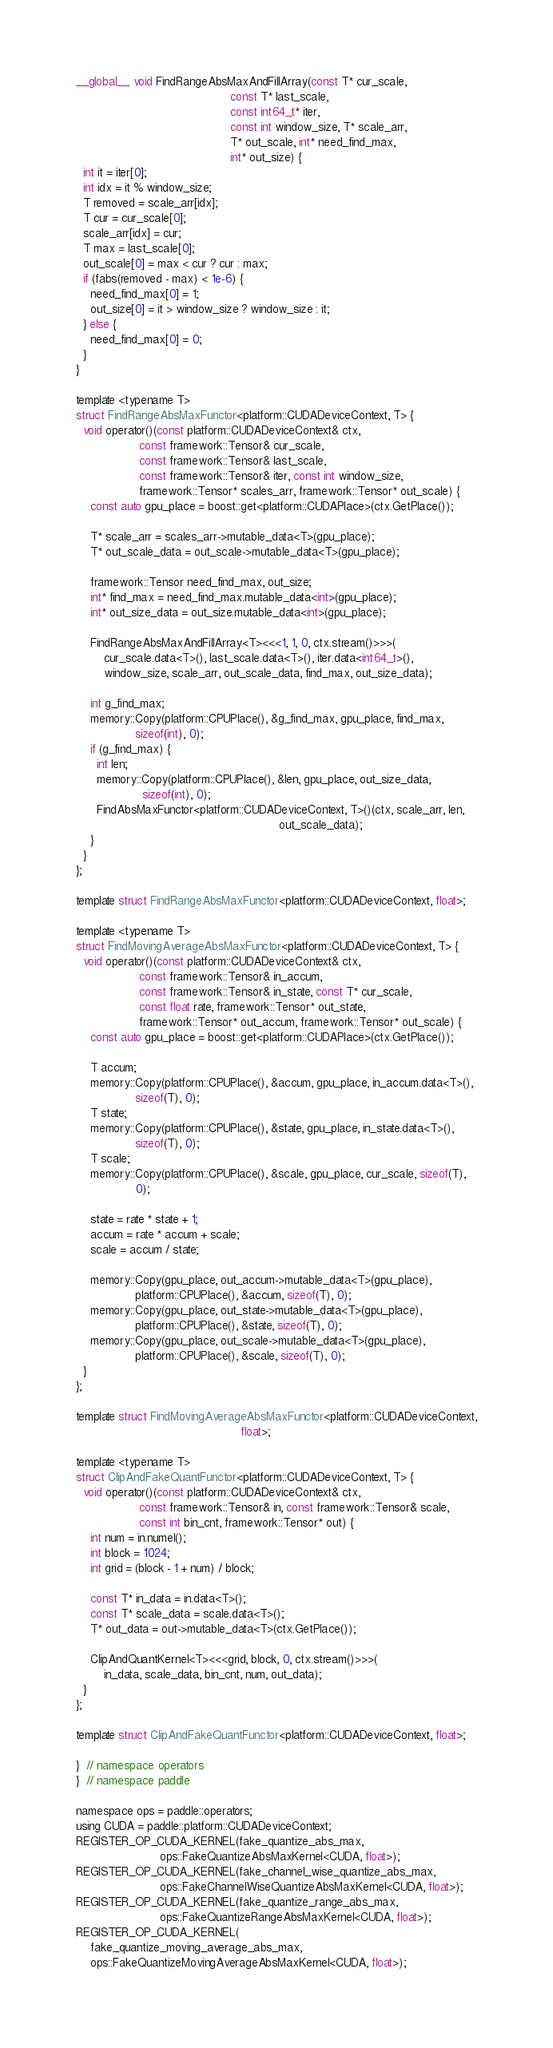<code> <loc_0><loc_0><loc_500><loc_500><_Cuda_>__global__ void FindRangeAbsMaxAndFillArray(const T* cur_scale,
                                            const T* last_scale,
                                            const int64_t* iter,
                                            const int window_size, T* scale_arr,
                                            T* out_scale, int* need_find_max,
                                            int* out_size) {
  int it = iter[0];
  int idx = it % window_size;
  T removed = scale_arr[idx];
  T cur = cur_scale[0];
  scale_arr[idx] = cur;
  T max = last_scale[0];
  out_scale[0] = max < cur ? cur : max;
  if (fabs(removed - max) < 1e-6) {
    need_find_max[0] = 1;
    out_size[0] = it > window_size ? window_size : it;
  } else {
    need_find_max[0] = 0;
  }
}

template <typename T>
struct FindRangeAbsMaxFunctor<platform::CUDADeviceContext, T> {
  void operator()(const platform::CUDADeviceContext& ctx,
                  const framework::Tensor& cur_scale,
                  const framework::Tensor& last_scale,
                  const framework::Tensor& iter, const int window_size,
                  framework::Tensor* scales_arr, framework::Tensor* out_scale) {
    const auto gpu_place = boost::get<platform::CUDAPlace>(ctx.GetPlace());

    T* scale_arr = scales_arr->mutable_data<T>(gpu_place);
    T* out_scale_data = out_scale->mutable_data<T>(gpu_place);

    framework::Tensor need_find_max, out_size;
    int* find_max = need_find_max.mutable_data<int>(gpu_place);
    int* out_size_data = out_size.mutable_data<int>(gpu_place);

    FindRangeAbsMaxAndFillArray<T><<<1, 1, 0, ctx.stream()>>>(
        cur_scale.data<T>(), last_scale.data<T>(), iter.data<int64_t>(),
        window_size, scale_arr, out_scale_data, find_max, out_size_data);

    int g_find_max;
    memory::Copy(platform::CPUPlace(), &g_find_max, gpu_place, find_max,
                 sizeof(int), 0);
    if (g_find_max) {
      int len;
      memory::Copy(platform::CPUPlace(), &len, gpu_place, out_size_data,
                   sizeof(int), 0);
      FindAbsMaxFunctor<platform::CUDADeviceContext, T>()(ctx, scale_arr, len,
                                                          out_scale_data);
    }
  }
};

template struct FindRangeAbsMaxFunctor<platform::CUDADeviceContext, float>;

template <typename T>
struct FindMovingAverageAbsMaxFunctor<platform::CUDADeviceContext, T> {
  void operator()(const platform::CUDADeviceContext& ctx,
                  const framework::Tensor& in_accum,
                  const framework::Tensor& in_state, const T* cur_scale,
                  const float rate, framework::Tensor* out_state,
                  framework::Tensor* out_accum, framework::Tensor* out_scale) {
    const auto gpu_place = boost::get<platform::CUDAPlace>(ctx.GetPlace());

    T accum;
    memory::Copy(platform::CPUPlace(), &accum, gpu_place, in_accum.data<T>(),
                 sizeof(T), 0);
    T state;
    memory::Copy(platform::CPUPlace(), &state, gpu_place, in_state.data<T>(),
                 sizeof(T), 0);
    T scale;
    memory::Copy(platform::CPUPlace(), &scale, gpu_place, cur_scale, sizeof(T),
                 0);

    state = rate * state + 1;
    accum = rate * accum + scale;
    scale = accum / state;

    memory::Copy(gpu_place, out_accum->mutable_data<T>(gpu_place),
                 platform::CPUPlace(), &accum, sizeof(T), 0);
    memory::Copy(gpu_place, out_state->mutable_data<T>(gpu_place),
                 platform::CPUPlace(), &state, sizeof(T), 0);
    memory::Copy(gpu_place, out_scale->mutable_data<T>(gpu_place),
                 platform::CPUPlace(), &scale, sizeof(T), 0);
  }
};

template struct FindMovingAverageAbsMaxFunctor<platform::CUDADeviceContext,
                                               float>;

template <typename T>
struct ClipAndFakeQuantFunctor<platform::CUDADeviceContext, T> {
  void operator()(const platform::CUDADeviceContext& ctx,
                  const framework::Tensor& in, const framework::Tensor& scale,
                  const int bin_cnt, framework::Tensor* out) {
    int num = in.numel();
    int block = 1024;
    int grid = (block - 1 + num) / block;

    const T* in_data = in.data<T>();
    const T* scale_data = scale.data<T>();
    T* out_data = out->mutable_data<T>(ctx.GetPlace());

    ClipAndQuantKernel<T><<<grid, block, 0, ctx.stream()>>>(
        in_data, scale_data, bin_cnt, num, out_data);
  }
};

template struct ClipAndFakeQuantFunctor<platform::CUDADeviceContext, float>;

}  // namespace operators
}  // namespace paddle

namespace ops = paddle::operators;
using CUDA = paddle::platform::CUDADeviceContext;
REGISTER_OP_CUDA_KERNEL(fake_quantize_abs_max,
                        ops::FakeQuantizeAbsMaxKernel<CUDA, float>);
REGISTER_OP_CUDA_KERNEL(fake_channel_wise_quantize_abs_max,
                        ops::FakeChannelWiseQuantizeAbsMaxKernel<CUDA, float>);
REGISTER_OP_CUDA_KERNEL(fake_quantize_range_abs_max,
                        ops::FakeQuantizeRangeAbsMaxKernel<CUDA, float>);
REGISTER_OP_CUDA_KERNEL(
    fake_quantize_moving_average_abs_max,
    ops::FakeQuantizeMovingAverageAbsMaxKernel<CUDA, float>);
</code> 